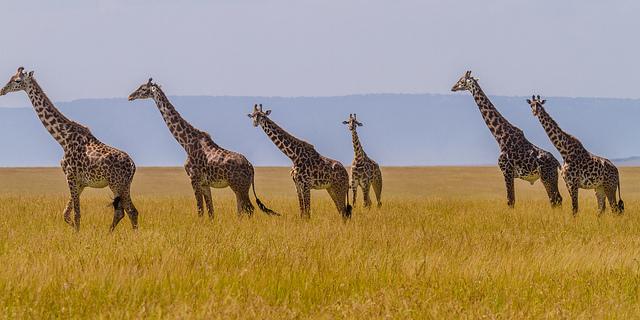What are the giraffes standing in?
Give a very brief answer. Grass. Is the last giraffe looking at the camera?
Give a very brief answer. Yes. Are the giraffes all the same size?
Be succinct. No. 